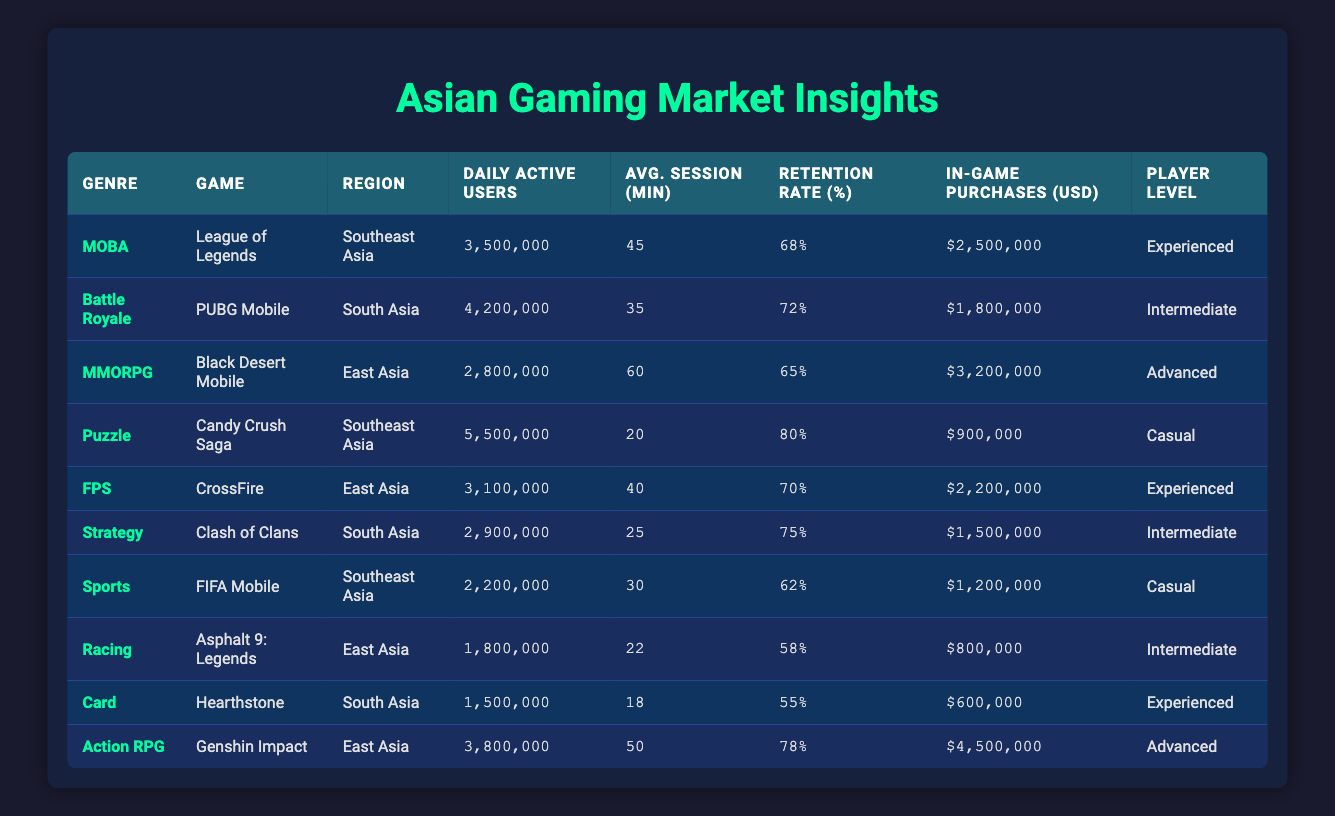What is the Daily Active Users count for Candy Crush Saga? The table shows the row for Candy Crush Saga under the Puzzle genre, which has a Daily Active Users count of 5,500,000.
Answer: 5,500,000 What is the retention rate of League of Legends? According to the table, the retention rate for League of Legends listed under the MOBA genre is 68%.
Answer: 68% Which game has the highest average session length? By comparing the Average Session Length values across the table, Black Desert Mobile has the highest at 60 minutes.
Answer: 60 Are there more Daily Active Users in Racing or Sports genre games? Looking at the Daily Active Users for Racing (1,800,000 for Asphalt 9: Legends) and Sports (2,200,000 for FIFA Mobile), Sports has more users.
Answer: Yes, Sports genre has more Daily Active Users What is the total number of Daily Active Users for all games in South Asia? The Daily Active Users for games in South Asia are as follows: PUBG Mobile (4,200,000) and Clash of Clans (2,900,000). Summing these gives: 4,200,000 + 2,900,000 = 7,100,000 total Daily Active Users.
Answer: 7,100,000 Which genre has the lowest average session length? By examining the Average Session Lengths, Racing (22 minutes for Asphalt 9: Legends) has the lowest session length among the genres listed.
Answer: Racing What is the average retention rate across all games in East Asia? The games listed under the East Asia region are Black Desert Mobile (65%), CrossFire (70%), and Genshin Impact (78%). Adding these gives: 65 + 70 + 78 = 213, and dividing by 3 gives an average of 71%.
Answer: 71% Is the in-game purchase total for Genshin Impact higher than the total for Candy Crush Saga? The total in-game purchases for Genshin Impact is $4,500,000, while for Candy Crush Saga, it is $900,000.Thus, Genshin Impact has significantly higher in-game purchases.
Answer: Yes What percentage of the players are classified as Advanced in the table? The games classified as Advanced are Black Desert Mobile and Genshin Impact. Since there are 10 games in total, with 2 classified as Advanced, the percentage is (2/10) * 100 = 20%.
Answer: 20% 